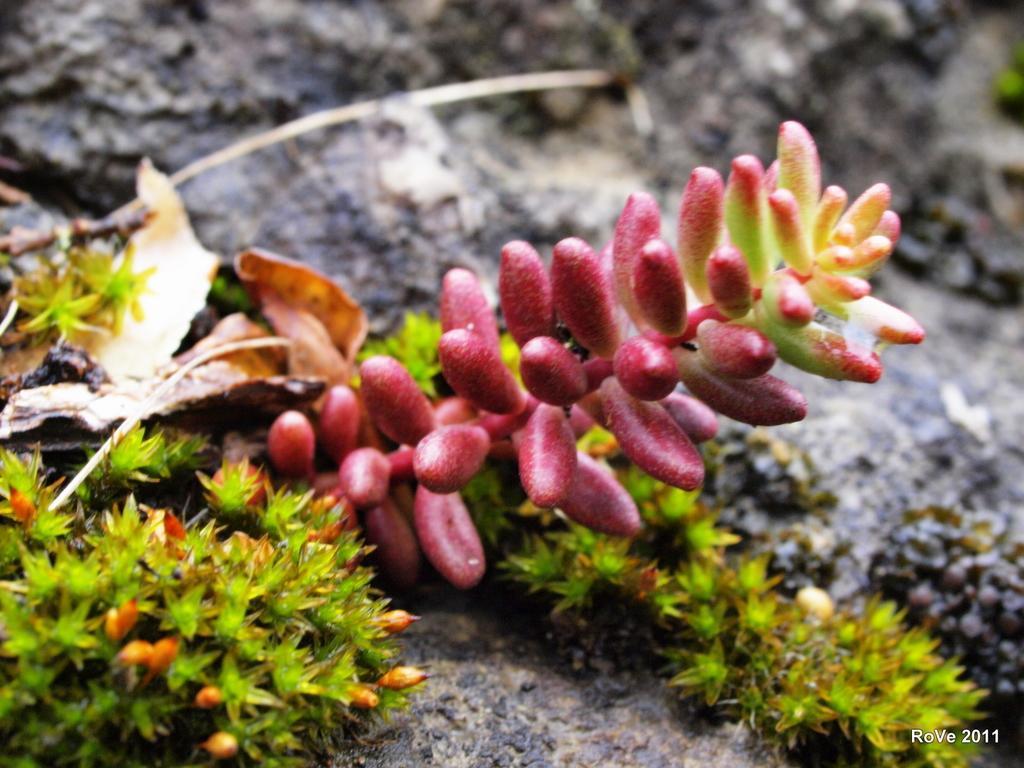In one or two sentences, can you explain what this image depicts? On the left side, there are plants having fruits and green color leaves and there is a dry leaf on a surface. And the background is blurred. 